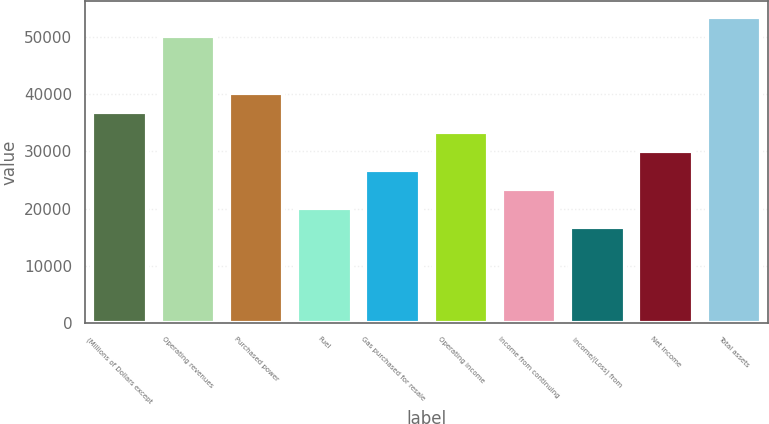Convert chart to OTSL. <chart><loc_0><loc_0><loc_500><loc_500><bar_chart><fcel>(Millions of Dollars except<fcel>Operating revenues<fcel>Purchased power<fcel>Fuel<fcel>Gas purchased for resale<fcel>Operating income<fcel>Income from continuing<fcel>Income/(Loss) from<fcel>Net income<fcel>Total assets<nl><fcel>36847.7<fcel>50246.5<fcel>40197.4<fcel>20099.2<fcel>26798.6<fcel>33498<fcel>23448.9<fcel>16749.5<fcel>30148.3<fcel>53596.2<nl></chart> 